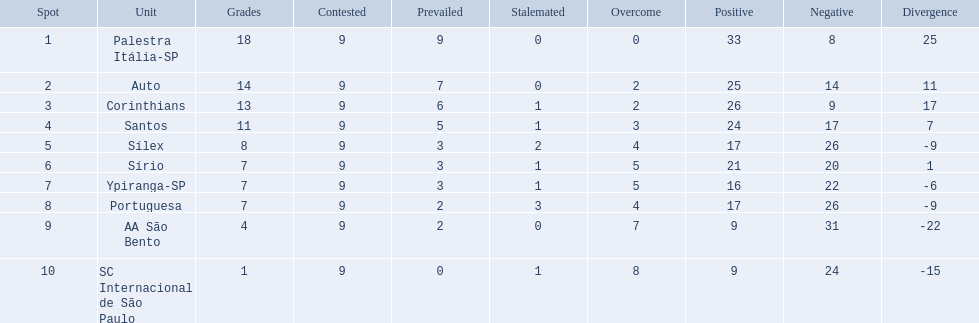What were all the teams that competed in 1926 brazilian football? Palestra Itália-SP, Auto, Corinthians, Santos, Sílex, Sírio, Ypiranga-SP, Portuguesa, AA São Bento, SC Internacional de São Paulo. Which of these had zero games lost? Palestra Itália-SP. 